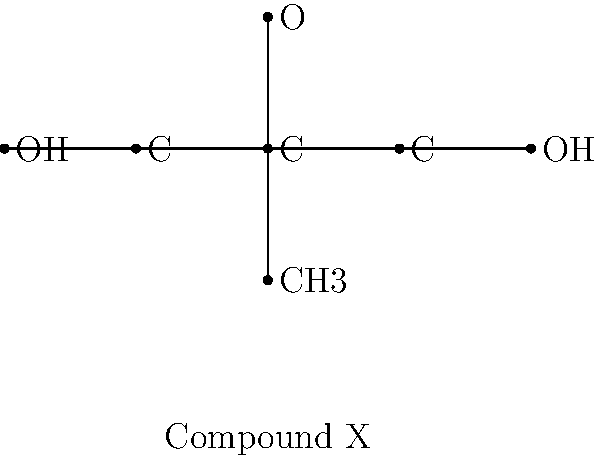A novel fungus species you recently discovered produces a bioactive compound with the molecular structure shown above (Compound X). Based on this structure, which of the following statements is most likely true about its potential biological activity?

a) It may act as a strong acid in cellular environments
b) It could potentially form hydrogen bonds with target proteins
c) It is likely to be highly lipophilic and pass through cell membranes easily
d) It would be expected to act as a powerful reducing agent To answer this question, we need to analyze the chemical structure of Compound X and consider how its features might influence its biological activity:

1. The compound contains two hydroxyl (OH) groups at the ends of the carbon chain. This suggests it has some polar character.

2. There is an oxygen atom (O) attached to the central carbon, forming an ether-like structure.

3. The presence of a methyl (CH3) group adds a small hydrophobic component.

4. The overall structure is relatively small and contains both hydrophilic (OH and O) and hydrophobic (CH3) components.

Let's evaluate each option:

a) Strong acid: The compound doesn't have any obviously acidic groups. Alcohols are very weak acids, so this is unlikely.

b) Hydrogen bonding: The presence of two hydroxyl (OH) groups makes this highly likely. These groups can act as both hydrogen bond donors and acceptors, potentially interacting with amino acid residues in proteins.

c) Highly lipophilic: While the compound has some hydrophobic character (CH3 group), the presence of two OH groups and an oxygen atom makes it more hydrophilic than lipophilic. It's unlikely to pass easily through cell membranes without assistance.

d) Powerful reducing agent: There's no evidence in the structure to suggest it would be a strong reducing agent. It lacks functional groups typically associated with reducing activity.

Given these considerations, option b is the most likely to be true. The compound's ability to form hydrogen bonds could play a crucial role in its interaction with biological targets, potentially contributing to its bioactivity.
Answer: b) It could potentially form hydrogen bonds with target proteins 